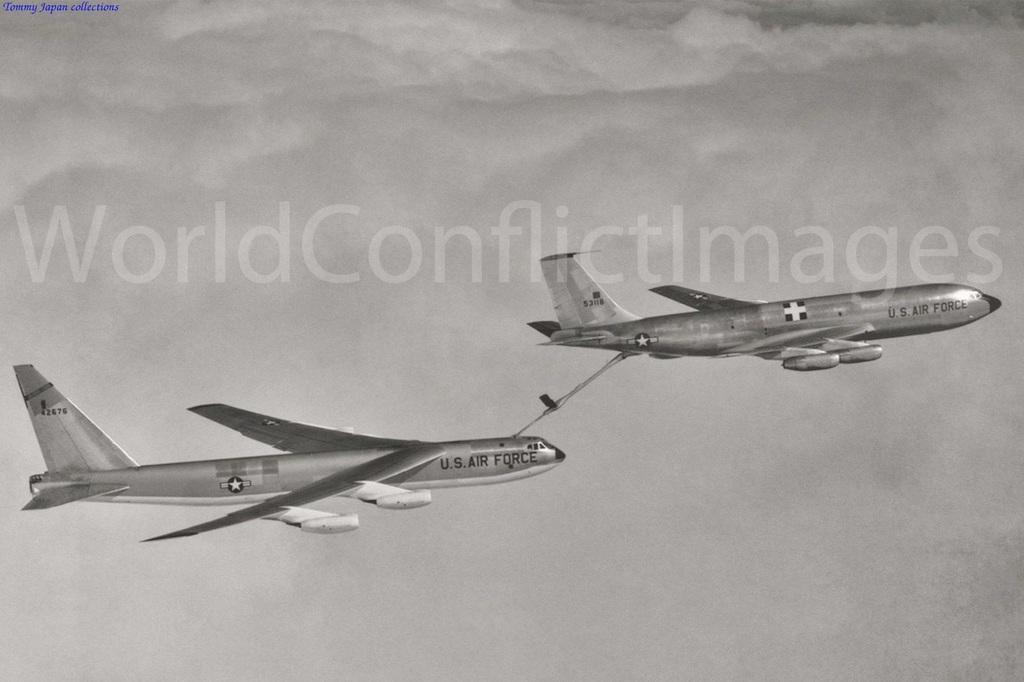How would you summarize this image in a sentence or two? In this image we can see aeroplanes flying in the sky. 